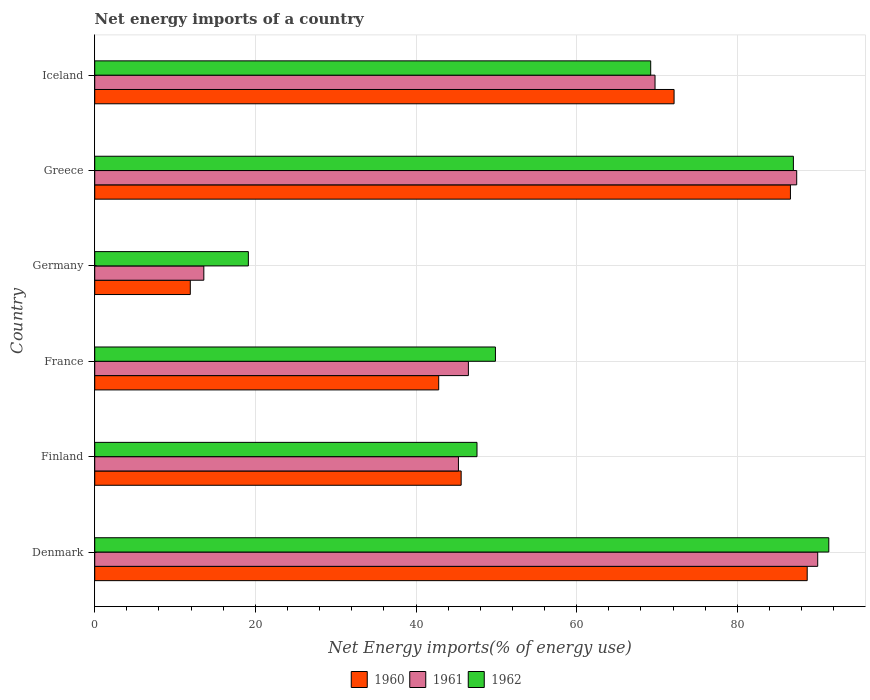How many groups of bars are there?
Make the answer very short. 6. Are the number of bars on each tick of the Y-axis equal?
Your response must be concise. Yes. What is the net energy imports in 1961 in Greece?
Your response must be concise. 87.4. Across all countries, what is the maximum net energy imports in 1960?
Ensure brevity in your answer.  88.7. Across all countries, what is the minimum net energy imports in 1962?
Your answer should be compact. 19.13. In which country was the net energy imports in 1960 maximum?
Provide a succinct answer. Denmark. In which country was the net energy imports in 1960 minimum?
Keep it short and to the point. Germany. What is the total net energy imports in 1961 in the graph?
Offer a very short reply. 352.54. What is the difference between the net energy imports in 1960 in Finland and that in Iceland?
Provide a succinct answer. -26.51. What is the difference between the net energy imports in 1960 in Denmark and the net energy imports in 1961 in Iceland?
Offer a terse response. 18.94. What is the average net energy imports in 1960 per country?
Offer a very short reply. 57.96. What is the difference between the net energy imports in 1960 and net energy imports in 1961 in Germany?
Your response must be concise. -1.68. What is the ratio of the net energy imports in 1962 in Denmark to that in Finland?
Keep it short and to the point. 1.92. What is the difference between the highest and the second highest net energy imports in 1961?
Offer a very short reply. 2.61. What is the difference between the highest and the lowest net energy imports in 1962?
Give a very brief answer. 72.26. Is the sum of the net energy imports in 1961 in France and Iceland greater than the maximum net energy imports in 1962 across all countries?
Make the answer very short. Yes. What does the 2nd bar from the top in France represents?
Ensure brevity in your answer.  1961. What does the 2nd bar from the bottom in Greece represents?
Your response must be concise. 1961. How many bars are there?
Your answer should be very brief. 18. What is the difference between two consecutive major ticks on the X-axis?
Offer a very short reply. 20. Are the values on the major ticks of X-axis written in scientific E-notation?
Provide a succinct answer. No. Where does the legend appear in the graph?
Offer a very short reply. Bottom center. What is the title of the graph?
Provide a short and direct response. Net energy imports of a country. Does "2002" appear as one of the legend labels in the graph?
Your response must be concise. No. What is the label or title of the X-axis?
Your answer should be compact. Net Energy imports(% of energy use). What is the Net Energy imports(% of energy use) in 1960 in Denmark?
Make the answer very short. 88.7. What is the Net Energy imports(% of energy use) in 1961 in Denmark?
Your response must be concise. 90.01. What is the Net Energy imports(% of energy use) of 1962 in Denmark?
Your answer should be very brief. 91.39. What is the Net Energy imports(% of energy use) of 1960 in Finland?
Offer a very short reply. 45.62. What is the Net Energy imports(% of energy use) of 1961 in Finland?
Make the answer very short. 45.28. What is the Net Energy imports(% of energy use) of 1962 in Finland?
Your answer should be very brief. 47.59. What is the Net Energy imports(% of energy use) in 1960 in France?
Your response must be concise. 42.82. What is the Net Energy imports(% of energy use) of 1961 in France?
Ensure brevity in your answer.  46.52. What is the Net Energy imports(% of energy use) in 1962 in France?
Make the answer very short. 49.89. What is the Net Energy imports(% of energy use) in 1960 in Germany?
Ensure brevity in your answer.  11.9. What is the Net Energy imports(% of energy use) in 1961 in Germany?
Give a very brief answer. 13.58. What is the Net Energy imports(% of energy use) of 1962 in Germany?
Provide a short and direct response. 19.13. What is the Net Energy imports(% of energy use) in 1960 in Greece?
Ensure brevity in your answer.  86.62. What is the Net Energy imports(% of energy use) of 1961 in Greece?
Offer a very short reply. 87.4. What is the Net Energy imports(% of energy use) in 1962 in Greece?
Your response must be concise. 86.98. What is the Net Energy imports(% of energy use) in 1960 in Iceland?
Offer a very short reply. 72.13. What is the Net Energy imports(% of energy use) in 1961 in Iceland?
Provide a succinct answer. 69.76. What is the Net Energy imports(% of energy use) in 1962 in Iceland?
Provide a short and direct response. 69.22. Across all countries, what is the maximum Net Energy imports(% of energy use) of 1960?
Give a very brief answer. 88.7. Across all countries, what is the maximum Net Energy imports(% of energy use) of 1961?
Provide a short and direct response. 90.01. Across all countries, what is the maximum Net Energy imports(% of energy use) of 1962?
Ensure brevity in your answer.  91.39. Across all countries, what is the minimum Net Energy imports(% of energy use) in 1960?
Keep it short and to the point. 11.9. Across all countries, what is the minimum Net Energy imports(% of energy use) of 1961?
Your answer should be very brief. 13.58. Across all countries, what is the minimum Net Energy imports(% of energy use) of 1962?
Your response must be concise. 19.13. What is the total Net Energy imports(% of energy use) of 1960 in the graph?
Make the answer very short. 347.79. What is the total Net Energy imports(% of energy use) in 1961 in the graph?
Give a very brief answer. 352.54. What is the total Net Energy imports(% of energy use) of 1962 in the graph?
Keep it short and to the point. 364.19. What is the difference between the Net Energy imports(% of energy use) in 1960 in Denmark and that in Finland?
Keep it short and to the point. 43.08. What is the difference between the Net Energy imports(% of energy use) of 1961 in Denmark and that in Finland?
Offer a very short reply. 44.73. What is the difference between the Net Energy imports(% of energy use) in 1962 in Denmark and that in Finland?
Your response must be concise. 43.8. What is the difference between the Net Energy imports(% of energy use) in 1960 in Denmark and that in France?
Your answer should be compact. 45.88. What is the difference between the Net Energy imports(% of energy use) in 1961 in Denmark and that in France?
Offer a very short reply. 43.49. What is the difference between the Net Energy imports(% of energy use) of 1962 in Denmark and that in France?
Provide a succinct answer. 41.5. What is the difference between the Net Energy imports(% of energy use) in 1960 in Denmark and that in Germany?
Provide a succinct answer. 76.8. What is the difference between the Net Energy imports(% of energy use) in 1961 in Denmark and that in Germany?
Your answer should be compact. 76.43. What is the difference between the Net Energy imports(% of energy use) of 1962 in Denmark and that in Germany?
Keep it short and to the point. 72.26. What is the difference between the Net Energy imports(% of energy use) in 1960 in Denmark and that in Greece?
Offer a very short reply. 2.09. What is the difference between the Net Energy imports(% of energy use) of 1961 in Denmark and that in Greece?
Keep it short and to the point. 2.61. What is the difference between the Net Energy imports(% of energy use) of 1962 in Denmark and that in Greece?
Keep it short and to the point. 4.41. What is the difference between the Net Energy imports(% of energy use) in 1960 in Denmark and that in Iceland?
Give a very brief answer. 16.57. What is the difference between the Net Energy imports(% of energy use) of 1961 in Denmark and that in Iceland?
Make the answer very short. 20.25. What is the difference between the Net Energy imports(% of energy use) in 1962 in Denmark and that in Iceland?
Offer a terse response. 22.17. What is the difference between the Net Energy imports(% of energy use) in 1960 in Finland and that in France?
Offer a terse response. 2.8. What is the difference between the Net Energy imports(% of energy use) of 1961 in Finland and that in France?
Your answer should be compact. -1.24. What is the difference between the Net Energy imports(% of energy use) of 1962 in Finland and that in France?
Keep it short and to the point. -2.3. What is the difference between the Net Energy imports(% of energy use) of 1960 in Finland and that in Germany?
Keep it short and to the point. 33.72. What is the difference between the Net Energy imports(% of energy use) in 1961 in Finland and that in Germany?
Keep it short and to the point. 31.7. What is the difference between the Net Energy imports(% of energy use) in 1962 in Finland and that in Germany?
Your response must be concise. 28.47. What is the difference between the Net Energy imports(% of energy use) in 1960 in Finland and that in Greece?
Provide a short and direct response. -41. What is the difference between the Net Energy imports(% of energy use) in 1961 in Finland and that in Greece?
Give a very brief answer. -42.12. What is the difference between the Net Energy imports(% of energy use) in 1962 in Finland and that in Greece?
Keep it short and to the point. -39.39. What is the difference between the Net Energy imports(% of energy use) in 1960 in Finland and that in Iceland?
Provide a short and direct response. -26.51. What is the difference between the Net Energy imports(% of energy use) in 1961 in Finland and that in Iceland?
Keep it short and to the point. -24.48. What is the difference between the Net Energy imports(% of energy use) in 1962 in Finland and that in Iceland?
Offer a very short reply. -21.63. What is the difference between the Net Energy imports(% of energy use) in 1960 in France and that in Germany?
Ensure brevity in your answer.  30.93. What is the difference between the Net Energy imports(% of energy use) of 1961 in France and that in Germany?
Keep it short and to the point. 32.94. What is the difference between the Net Energy imports(% of energy use) of 1962 in France and that in Germany?
Offer a terse response. 30.76. What is the difference between the Net Energy imports(% of energy use) of 1960 in France and that in Greece?
Ensure brevity in your answer.  -43.79. What is the difference between the Net Energy imports(% of energy use) of 1961 in France and that in Greece?
Give a very brief answer. -40.87. What is the difference between the Net Energy imports(% of energy use) of 1962 in France and that in Greece?
Your answer should be compact. -37.09. What is the difference between the Net Energy imports(% of energy use) of 1960 in France and that in Iceland?
Your response must be concise. -29.3. What is the difference between the Net Energy imports(% of energy use) of 1961 in France and that in Iceland?
Your answer should be very brief. -23.24. What is the difference between the Net Energy imports(% of energy use) in 1962 in France and that in Iceland?
Give a very brief answer. -19.33. What is the difference between the Net Energy imports(% of energy use) of 1960 in Germany and that in Greece?
Offer a terse response. -74.72. What is the difference between the Net Energy imports(% of energy use) in 1961 in Germany and that in Greece?
Provide a succinct answer. -73.81. What is the difference between the Net Energy imports(% of energy use) of 1962 in Germany and that in Greece?
Give a very brief answer. -67.86. What is the difference between the Net Energy imports(% of energy use) of 1960 in Germany and that in Iceland?
Make the answer very short. -60.23. What is the difference between the Net Energy imports(% of energy use) of 1961 in Germany and that in Iceland?
Your response must be concise. -56.17. What is the difference between the Net Energy imports(% of energy use) of 1962 in Germany and that in Iceland?
Your response must be concise. -50.09. What is the difference between the Net Energy imports(% of energy use) in 1960 in Greece and that in Iceland?
Make the answer very short. 14.49. What is the difference between the Net Energy imports(% of energy use) in 1961 in Greece and that in Iceland?
Your answer should be very brief. 17.64. What is the difference between the Net Energy imports(% of energy use) of 1962 in Greece and that in Iceland?
Ensure brevity in your answer.  17.77. What is the difference between the Net Energy imports(% of energy use) in 1960 in Denmark and the Net Energy imports(% of energy use) in 1961 in Finland?
Offer a terse response. 43.42. What is the difference between the Net Energy imports(% of energy use) in 1960 in Denmark and the Net Energy imports(% of energy use) in 1962 in Finland?
Keep it short and to the point. 41.11. What is the difference between the Net Energy imports(% of energy use) in 1961 in Denmark and the Net Energy imports(% of energy use) in 1962 in Finland?
Make the answer very short. 42.42. What is the difference between the Net Energy imports(% of energy use) in 1960 in Denmark and the Net Energy imports(% of energy use) in 1961 in France?
Give a very brief answer. 42.18. What is the difference between the Net Energy imports(% of energy use) in 1960 in Denmark and the Net Energy imports(% of energy use) in 1962 in France?
Your answer should be compact. 38.81. What is the difference between the Net Energy imports(% of energy use) in 1961 in Denmark and the Net Energy imports(% of energy use) in 1962 in France?
Your answer should be compact. 40.12. What is the difference between the Net Energy imports(% of energy use) in 1960 in Denmark and the Net Energy imports(% of energy use) in 1961 in Germany?
Provide a succinct answer. 75.12. What is the difference between the Net Energy imports(% of energy use) of 1960 in Denmark and the Net Energy imports(% of energy use) of 1962 in Germany?
Give a very brief answer. 69.58. What is the difference between the Net Energy imports(% of energy use) in 1961 in Denmark and the Net Energy imports(% of energy use) in 1962 in Germany?
Offer a terse response. 70.88. What is the difference between the Net Energy imports(% of energy use) in 1960 in Denmark and the Net Energy imports(% of energy use) in 1961 in Greece?
Provide a short and direct response. 1.31. What is the difference between the Net Energy imports(% of energy use) in 1960 in Denmark and the Net Energy imports(% of energy use) in 1962 in Greece?
Your answer should be very brief. 1.72. What is the difference between the Net Energy imports(% of energy use) in 1961 in Denmark and the Net Energy imports(% of energy use) in 1962 in Greece?
Offer a very short reply. 3.03. What is the difference between the Net Energy imports(% of energy use) in 1960 in Denmark and the Net Energy imports(% of energy use) in 1961 in Iceland?
Make the answer very short. 18.94. What is the difference between the Net Energy imports(% of energy use) in 1960 in Denmark and the Net Energy imports(% of energy use) in 1962 in Iceland?
Give a very brief answer. 19.48. What is the difference between the Net Energy imports(% of energy use) in 1961 in Denmark and the Net Energy imports(% of energy use) in 1962 in Iceland?
Offer a terse response. 20.79. What is the difference between the Net Energy imports(% of energy use) of 1960 in Finland and the Net Energy imports(% of energy use) of 1961 in France?
Offer a terse response. -0.9. What is the difference between the Net Energy imports(% of energy use) in 1960 in Finland and the Net Energy imports(% of energy use) in 1962 in France?
Make the answer very short. -4.27. What is the difference between the Net Energy imports(% of energy use) in 1961 in Finland and the Net Energy imports(% of energy use) in 1962 in France?
Offer a terse response. -4.61. What is the difference between the Net Energy imports(% of energy use) of 1960 in Finland and the Net Energy imports(% of energy use) of 1961 in Germany?
Your answer should be compact. 32.04. What is the difference between the Net Energy imports(% of energy use) of 1960 in Finland and the Net Energy imports(% of energy use) of 1962 in Germany?
Make the answer very short. 26.49. What is the difference between the Net Energy imports(% of energy use) of 1961 in Finland and the Net Energy imports(% of energy use) of 1962 in Germany?
Make the answer very short. 26.15. What is the difference between the Net Energy imports(% of energy use) in 1960 in Finland and the Net Energy imports(% of energy use) in 1961 in Greece?
Your answer should be very brief. -41.78. What is the difference between the Net Energy imports(% of energy use) in 1960 in Finland and the Net Energy imports(% of energy use) in 1962 in Greece?
Offer a very short reply. -41.36. What is the difference between the Net Energy imports(% of energy use) in 1961 in Finland and the Net Energy imports(% of energy use) in 1962 in Greece?
Offer a very short reply. -41.7. What is the difference between the Net Energy imports(% of energy use) in 1960 in Finland and the Net Energy imports(% of energy use) in 1961 in Iceland?
Provide a short and direct response. -24.14. What is the difference between the Net Energy imports(% of energy use) of 1960 in Finland and the Net Energy imports(% of energy use) of 1962 in Iceland?
Keep it short and to the point. -23.6. What is the difference between the Net Energy imports(% of energy use) of 1961 in Finland and the Net Energy imports(% of energy use) of 1962 in Iceland?
Provide a succinct answer. -23.94. What is the difference between the Net Energy imports(% of energy use) of 1960 in France and the Net Energy imports(% of energy use) of 1961 in Germany?
Ensure brevity in your answer.  29.24. What is the difference between the Net Energy imports(% of energy use) of 1960 in France and the Net Energy imports(% of energy use) of 1962 in Germany?
Give a very brief answer. 23.7. What is the difference between the Net Energy imports(% of energy use) of 1961 in France and the Net Energy imports(% of energy use) of 1962 in Germany?
Provide a short and direct response. 27.39. What is the difference between the Net Energy imports(% of energy use) in 1960 in France and the Net Energy imports(% of energy use) in 1961 in Greece?
Ensure brevity in your answer.  -44.57. What is the difference between the Net Energy imports(% of energy use) in 1960 in France and the Net Energy imports(% of energy use) in 1962 in Greece?
Provide a succinct answer. -44.16. What is the difference between the Net Energy imports(% of energy use) in 1961 in France and the Net Energy imports(% of energy use) in 1962 in Greece?
Keep it short and to the point. -40.46. What is the difference between the Net Energy imports(% of energy use) in 1960 in France and the Net Energy imports(% of energy use) in 1961 in Iceland?
Offer a terse response. -26.93. What is the difference between the Net Energy imports(% of energy use) in 1960 in France and the Net Energy imports(% of energy use) in 1962 in Iceland?
Make the answer very short. -26.39. What is the difference between the Net Energy imports(% of energy use) in 1961 in France and the Net Energy imports(% of energy use) in 1962 in Iceland?
Keep it short and to the point. -22.7. What is the difference between the Net Energy imports(% of energy use) of 1960 in Germany and the Net Energy imports(% of energy use) of 1961 in Greece?
Make the answer very short. -75.5. What is the difference between the Net Energy imports(% of energy use) of 1960 in Germany and the Net Energy imports(% of energy use) of 1962 in Greece?
Offer a very short reply. -75.08. What is the difference between the Net Energy imports(% of energy use) of 1961 in Germany and the Net Energy imports(% of energy use) of 1962 in Greece?
Provide a short and direct response. -73.4. What is the difference between the Net Energy imports(% of energy use) in 1960 in Germany and the Net Energy imports(% of energy use) in 1961 in Iceland?
Offer a very short reply. -57.86. What is the difference between the Net Energy imports(% of energy use) of 1960 in Germany and the Net Energy imports(% of energy use) of 1962 in Iceland?
Ensure brevity in your answer.  -57.32. What is the difference between the Net Energy imports(% of energy use) in 1961 in Germany and the Net Energy imports(% of energy use) in 1962 in Iceland?
Your response must be concise. -55.63. What is the difference between the Net Energy imports(% of energy use) of 1960 in Greece and the Net Energy imports(% of energy use) of 1961 in Iceland?
Your response must be concise. 16.86. What is the difference between the Net Energy imports(% of energy use) in 1960 in Greece and the Net Energy imports(% of energy use) in 1962 in Iceland?
Ensure brevity in your answer.  17.4. What is the difference between the Net Energy imports(% of energy use) of 1961 in Greece and the Net Energy imports(% of energy use) of 1962 in Iceland?
Give a very brief answer. 18.18. What is the average Net Energy imports(% of energy use) of 1960 per country?
Offer a terse response. 57.96. What is the average Net Energy imports(% of energy use) in 1961 per country?
Provide a succinct answer. 58.76. What is the average Net Energy imports(% of energy use) in 1962 per country?
Your answer should be very brief. 60.7. What is the difference between the Net Energy imports(% of energy use) of 1960 and Net Energy imports(% of energy use) of 1961 in Denmark?
Your response must be concise. -1.31. What is the difference between the Net Energy imports(% of energy use) in 1960 and Net Energy imports(% of energy use) in 1962 in Denmark?
Give a very brief answer. -2.69. What is the difference between the Net Energy imports(% of energy use) of 1961 and Net Energy imports(% of energy use) of 1962 in Denmark?
Provide a short and direct response. -1.38. What is the difference between the Net Energy imports(% of energy use) of 1960 and Net Energy imports(% of energy use) of 1961 in Finland?
Offer a very short reply. 0.34. What is the difference between the Net Energy imports(% of energy use) of 1960 and Net Energy imports(% of energy use) of 1962 in Finland?
Your answer should be compact. -1.97. What is the difference between the Net Energy imports(% of energy use) of 1961 and Net Energy imports(% of energy use) of 1962 in Finland?
Your response must be concise. -2.31. What is the difference between the Net Energy imports(% of energy use) of 1960 and Net Energy imports(% of energy use) of 1961 in France?
Ensure brevity in your answer.  -3.7. What is the difference between the Net Energy imports(% of energy use) in 1960 and Net Energy imports(% of energy use) in 1962 in France?
Offer a very short reply. -7.06. What is the difference between the Net Energy imports(% of energy use) of 1961 and Net Energy imports(% of energy use) of 1962 in France?
Offer a very short reply. -3.37. What is the difference between the Net Energy imports(% of energy use) in 1960 and Net Energy imports(% of energy use) in 1961 in Germany?
Your answer should be very brief. -1.68. What is the difference between the Net Energy imports(% of energy use) in 1960 and Net Energy imports(% of energy use) in 1962 in Germany?
Give a very brief answer. -7.23. What is the difference between the Net Energy imports(% of energy use) in 1961 and Net Energy imports(% of energy use) in 1962 in Germany?
Provide a succinct answer. -5.54. What is the difference between the Net Energy imports(% of energy use) of 1960 and Net Energy imports(% of energy use) of 1961 in Greece?
Your answer should be very brief. -0.78. What is the difference between the Net Energy imports(% of energy use) of 1960 and Net Energy imports(% of energy use) of 1962 in Greece?
Give a very brief answer. -0.37. What is the difference between the Net Energy imports(% of energy use) of 1961 and Net Energy imports(% of energy use) of 1962 in Greece?
Your response must be concise. 0.41. What is the difference between the Net Energy imports(% of energy use) of 1960 and Net Energy imports(% of energy use) of 1961 in Iceland?
Ensure brevity in your answer.  2.37. What is the difference between the Net Energy imports(% of energy use) of 1960 and Net Energy imports(% of energy use) of 1962 in Iceland?
Provide a succinct answer. 2.91. What is the difference between the Net Energy imports(% of energy use) in 1961 and Net Energy imports(% of energy use) in 1962 in Iceland?
Offer a very short reply. 0.54. What is the ratio of the Net Energy imports(% of energy use) of 1960 in Denmark to that in Finland?
Ensure brevity in your answer.  1.94. What is the ratio of the Net Energy imports(% of energy use) in 1961 in Denmark to that in Finland?
Your response must be concise. 1.99. What is the ratio of the Net Energy imports(% of energy use) in 1962 in Denmark to that in Finland?
Make the answer very short. 1.92. What is the ratio of the Net Energy imports(% of energy use) in 1960 in Denmark to that in France?
Give a very brief answer. 2.07. What is the ratio of the Net Energy imports(% of energy use) of 1961 in Denmark to that in France?
Provide a succinct answer. 1.93. What is the ratio of the Net Energy imports(% of energy use) of 1962 in Denmark to that in France?
Give a very brief answer. 1.83. What is the ratio of the Net Energy imports(% of energy use) of 1960 in Denmark to that in Germany?
Your answer should be very brief. 7.46. What is the ratio of the Net Energy imports(% of energy use) in 1961 in Denmark to that in Germany?
Provide a succinct answer. 6.63. What is the ratio of the Net Energy imports(% of energy use) of 1962 in Denmark to that in Germany?
Give a very brief answer. 4.78. What is the ratio of the Net Energy imports(% of energy use) in 1960 in Denmark to that in Greece?
Offer a terse response. 1.02. What is the ratio of the Net Energy imports(% of energy use) in 1961 in Denmark to that in Greece?
Offer a very short reply. 1.03. What is the ratio of the Net Energy imports(% of energy use) in 1962 in Denmark to that in Greece?
Provide a short and direct response. 1.05. What is the ratio of the Net Energy imports(% of energy use) of 1960 in Denmark to that in Iceland?
Provide a succinct answer. 1.23. What is the ratio of the Net Energy imports(% of energy use) of 1961 in Denmark to that in Iceland?
Your response must be concise. 1.29. What is the ratio of the Net Energy imports(% of energy use) in 1962 in Denmark to that in Iceland?
Provide a succinct answer. 1.32. What is the ratio of the Net Energy imports(% of energy use) of 1960 in Finland to that in France?
Your response must be concise. 1.07. What is the ratio of the Net Energy imports(% of energy use) of 1961 in Finland to that in France?
Offer a very short reply. 0.97. What is the ratio of the Net Energy imports(% of energy use) of 1962 in Finland to that in France?
Offer a terse response. 0.95. What is the ratio of the Net Energy imports(% of energy use) in 1960 in Finland to that in Germany?
Give a very brief answer. 3.83. What is the ratio of the Net Energy imports(% of energy use) of 1961 in Finland to that in Germany?
Your response must be concise. 3.33. What is the ratio of the Net Energy imports(% of energy use) of 1962 in Finland to that in Germany?
Offer a very short reply. 2.49. What is the ratio of the Net Energy imports(% of energy use) of 1960 in Finland to that in Greece?
Provide a succinct answer. 0.53. What is the ratio of the Net Energy imports(% of energy use) in 1961 in Finland to that in Greece?
Provide a succinct answer. 0.52. What is the ratio of the Net Energy imports(% of energy use) of 1962 in Finland to that in Greece?
Offer a terse response. 0.55. What is the ratio of the Net Energy imports(% of energy use) in 1960 in Finland to that in Iceland?
Give a very brief answer. 0.63. What is the ratio of the Net Energy imports(% of energy use) of 1961 in Finland to that in Iceland?
Your response must be concise. 0.65. What is the ratio of the Net Energy imports(% of energy use) in 1962 in Finland to that in Iceland?
Provide a short and direct response. 0.69. What is the ratio of the Net Energy imports(% of energy use) of 1960 in France to that in Germany?
Provide a short and direct response. 3.6. What is the ratio of the Net Energy imports(% of energy use) of 1961 in France to that in Germany?
Make the answer very short. 3.43. What is the ratio of the Net Energy imports(% of energy use) in 1962 in France to that in Germany?
Keep it short and to the point. 2.61. What is the ratio of the Net Energy imports(% of energy use) in 1960 in France to that in Greece?
Your answer should be very brief. 0.49. What is the ratio of the Net Energy imports(% of energy use) of 1961 in France to that in Greece?
Your answer should be compact. 0.53. What is the ratio of the Net Energy imports(% of energy use) of 1962 in France to that in Greece?
Your answer should be compact. 0.57. What is the ratio of the Net Energy imports(% of energy use) of 1960 in France to that in Iceland?
Your answer should be compact. 0.59. What is the ratio of the Net Energy imports(% of energy use) in 1961 in France to that in Iceland?
Offer a terse response. 0.67. What is the ratio of the Net Energy imports(% of energy use) of 1962 in France to that in Iceland?
Offer a terse response. 0.72. What is the ratio of the Net Energy imports(% of energy use) in 1960 in Germany to that in Greece?
Keep it short and to the point. 0.14. What is the ratio of the Net Energy imports(% of energy use) of 1961 in Germany to that in Greece?
Your response must be concise. 0.16. What is the ratio of the Net Energy imports(% of energy use) in 1962 in Germany to that in Greece?
Your answer should be very brief. 0.22. What is the ratio of the Net Energy imports(% of energy use) of 1960 in Germany to that in Iceland?
Your answer should be very brief. 0.17. What is the ratio of the Net Energy imports(% of energy use) of 1961 in Germany to that in Iceland?
Ensure brevity in your answer.  0.19. What is the ratio of the Net Energy imports(% of energy use) of 1962 in Germany to that in Iceland?
Make the answer very short. 0.28. What is the ratio of the Net Energy imports(% of energy use) of 1960 in Greece to that in Iceland?
Your answer should be compact. 1.2. What is the ratio of the Net Energy imports(% of energy use) of 1961 in Greece to that in Iceland?
Offer a terse response. 1.25. What is the ratio of the Net Energy imports(% of energy use) of 1962 in Greece to that in Iceland?
Give a very brief answer. 1.26. What is the difference between the highest and the second highest Net Energy imports(% of energy use) of 1960?
Make the answer very short. 2.09. What is the difference between the highest and the second highest Net Energy imports(% of energy use) of 1961?
Make the answer very short. 2.61. What is the difference between the highest and the second highest Net Energy imports(% of energy use) in 1962?
Ensure brevity in your answer.  4.41. What is the difference between the highest and the lowest Net Energy imports(% of energy use) of 1960?
Give a very brief answer. 76.8. What is the difference between the highest and the lowest Net Energy imports(% of energy use) in 1961?
Make the answer very short. 76.43. What is the difference between the highest and the lowest Net Energy imports(% of energy use) of 1962?
Make the answer very short. 72.26. 